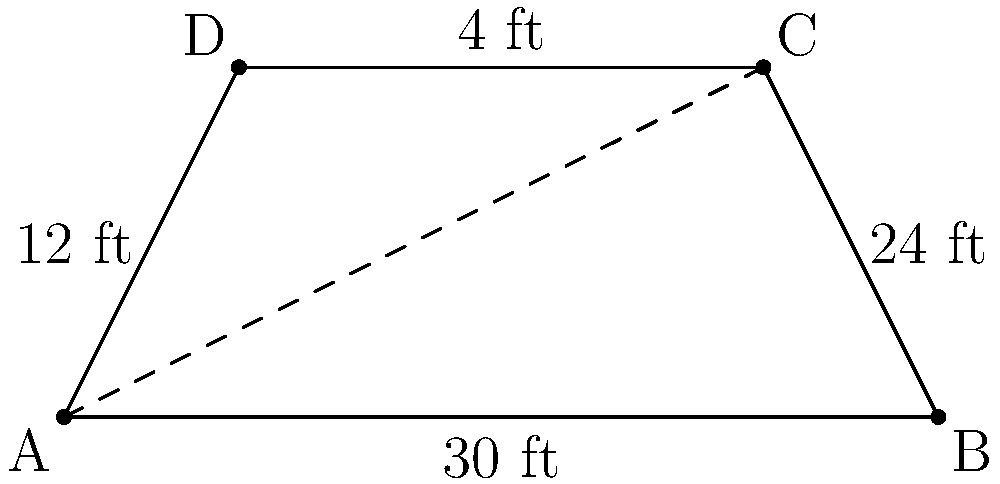As a veteran wrestling fan, you're analyzing the new entrance ramp design for an upcoming pay-per-view event. The ramp has a trapezoid shape, with the wider end at the stage and the narrower end leading to the ring. The stage end is 30 feet wide, the ring end is 12 feet wide, and the length of the ramp is 24 feet. What is the total area of this new entrance ramp in square feet? Let's approach this step-by-step:

1) The shape of the ramp is a trapezoid. The formula for the area of a trapezoid is:

   $$A = \frac{(a+b)h}{2}$$

   where $A$ is the area, $a$ and $b$ are the lengths of the parallel sides, and $h$ is the height (or length in this case) of the trapezoid.

2) From the given information:
   - $a = 30$ ft (stage end width)
   - $b = 12$ ft (ring end width)
   - $h = 24$ ft (length of the ramp)

3) Let's substitute these values into the formula:

   $$A = \frac{(30+12) \times 24}{2}$$

4) Simplify:
   $$A = \frac{42 \times 24}{2}$$

5) Calculate:
   $$A = \frac{1008}{2} = 504$$

Therefore, the total area of the entrance ramp is 504 square feet.
Answer: 504 sq ft 